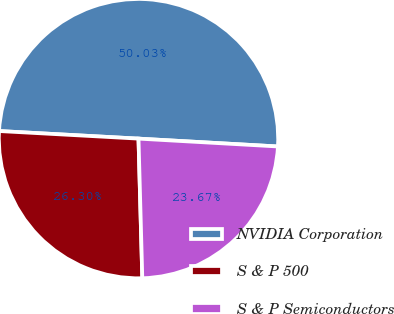Convert chart. <chart><loc_0><loc_0><loc_500><loc_500><pie_chart><fcel>NVIDIA Corporation<fcel>S & P 500<fcel>S & P Semiconductors<nl><fcel>50.03%<fcel>26.3%<fcel>23.67%<nl></chart> 